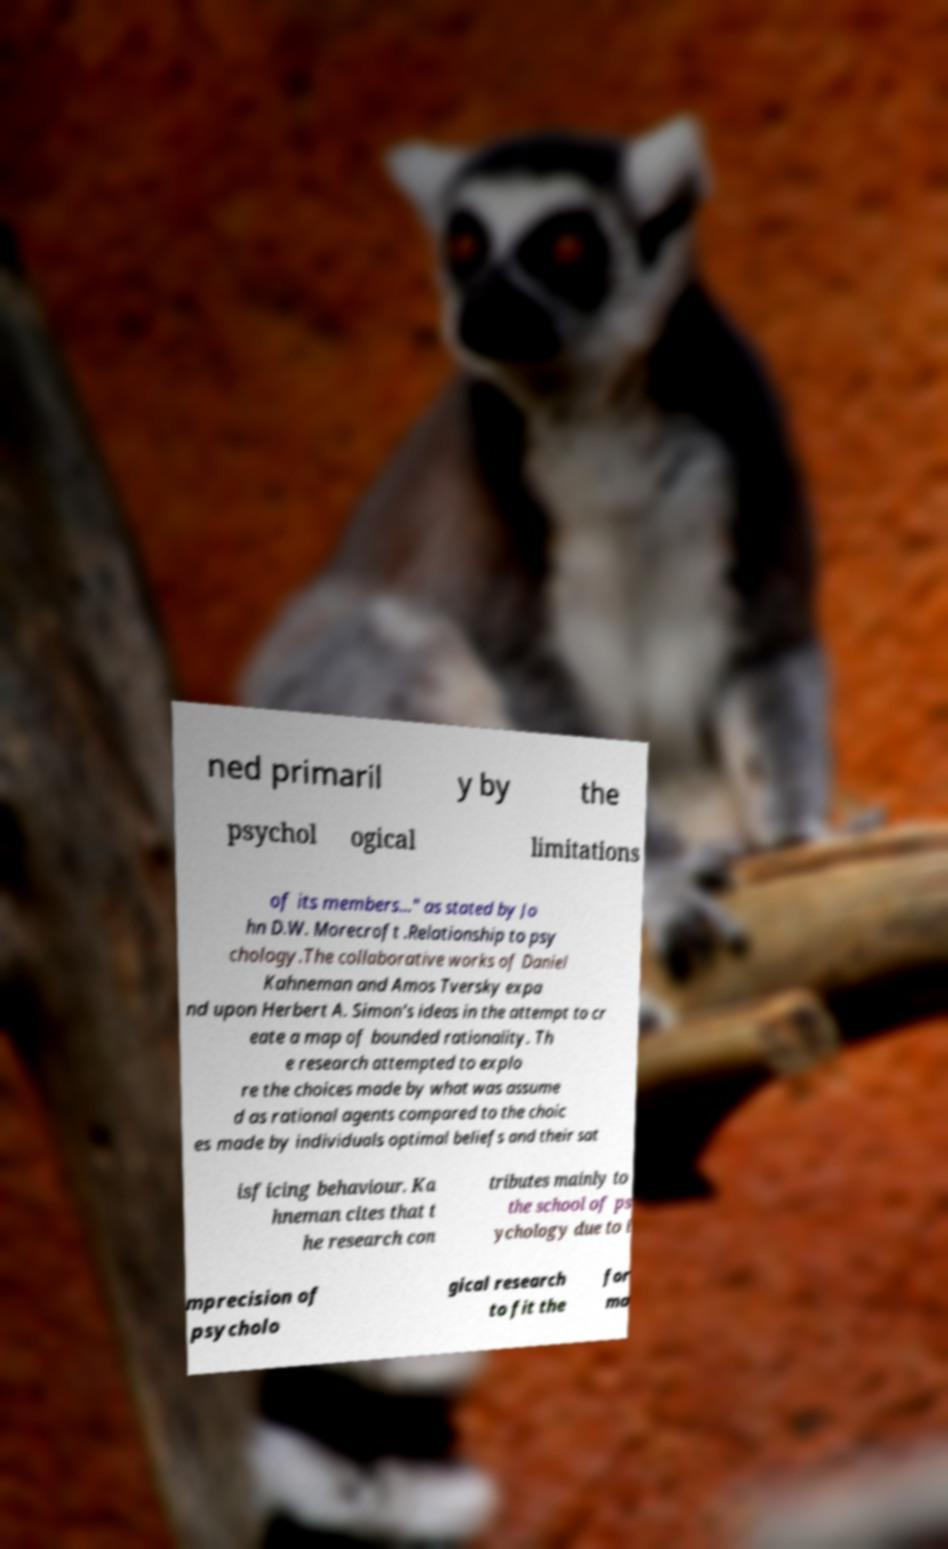Please read and relay the text visible in this image. What does it say? ned primaril y by the psychol ogical limitations of its members..." as stated by Jo hn D.W. Morecroft .Relationship to psy chology.The collaborative works of Daniel Kahneman and Amos Tversky expa nd upon Herbert A. Simon's ideas in the attempt to cr eate a map of bounded rationality. Th e research attempted to explo re the choices made by what was assume d as rational agents compared to the choic es made by individuals optimal beliefs and their sat isficing behaviour. Ka hneman cites that t he research con tributes mainly to the school of ps ychology due to i mprecision of psycholo gical research to fit the for ma 